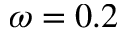Convert formula to latex. <formula><loc_0><loc_0><loc_500><loc_500>\omega = 0 . 2</formula> 